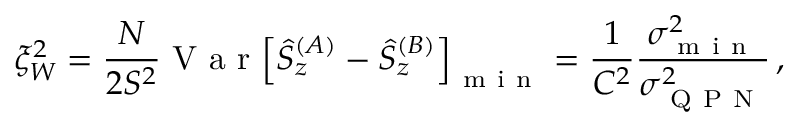<formula> <loc_0><loc_0><loc_500><loc_500>\xi _ { W } ^ { 2 } = \frac { N } { 2 S ^ { 2 } } V a r { \left [ \hat { S } _ { z } ^ { ( A ) } - \hat { S } _ { z } ^ { ( B ) } \right ] } _ { m i n } = \frac { 1 } { C ^ { 2 } } \frac { \sigma _ { m i n } ^ { 2 } } { \sigma _ { Q P N } ^ { 2 } } \, ,</formula> 